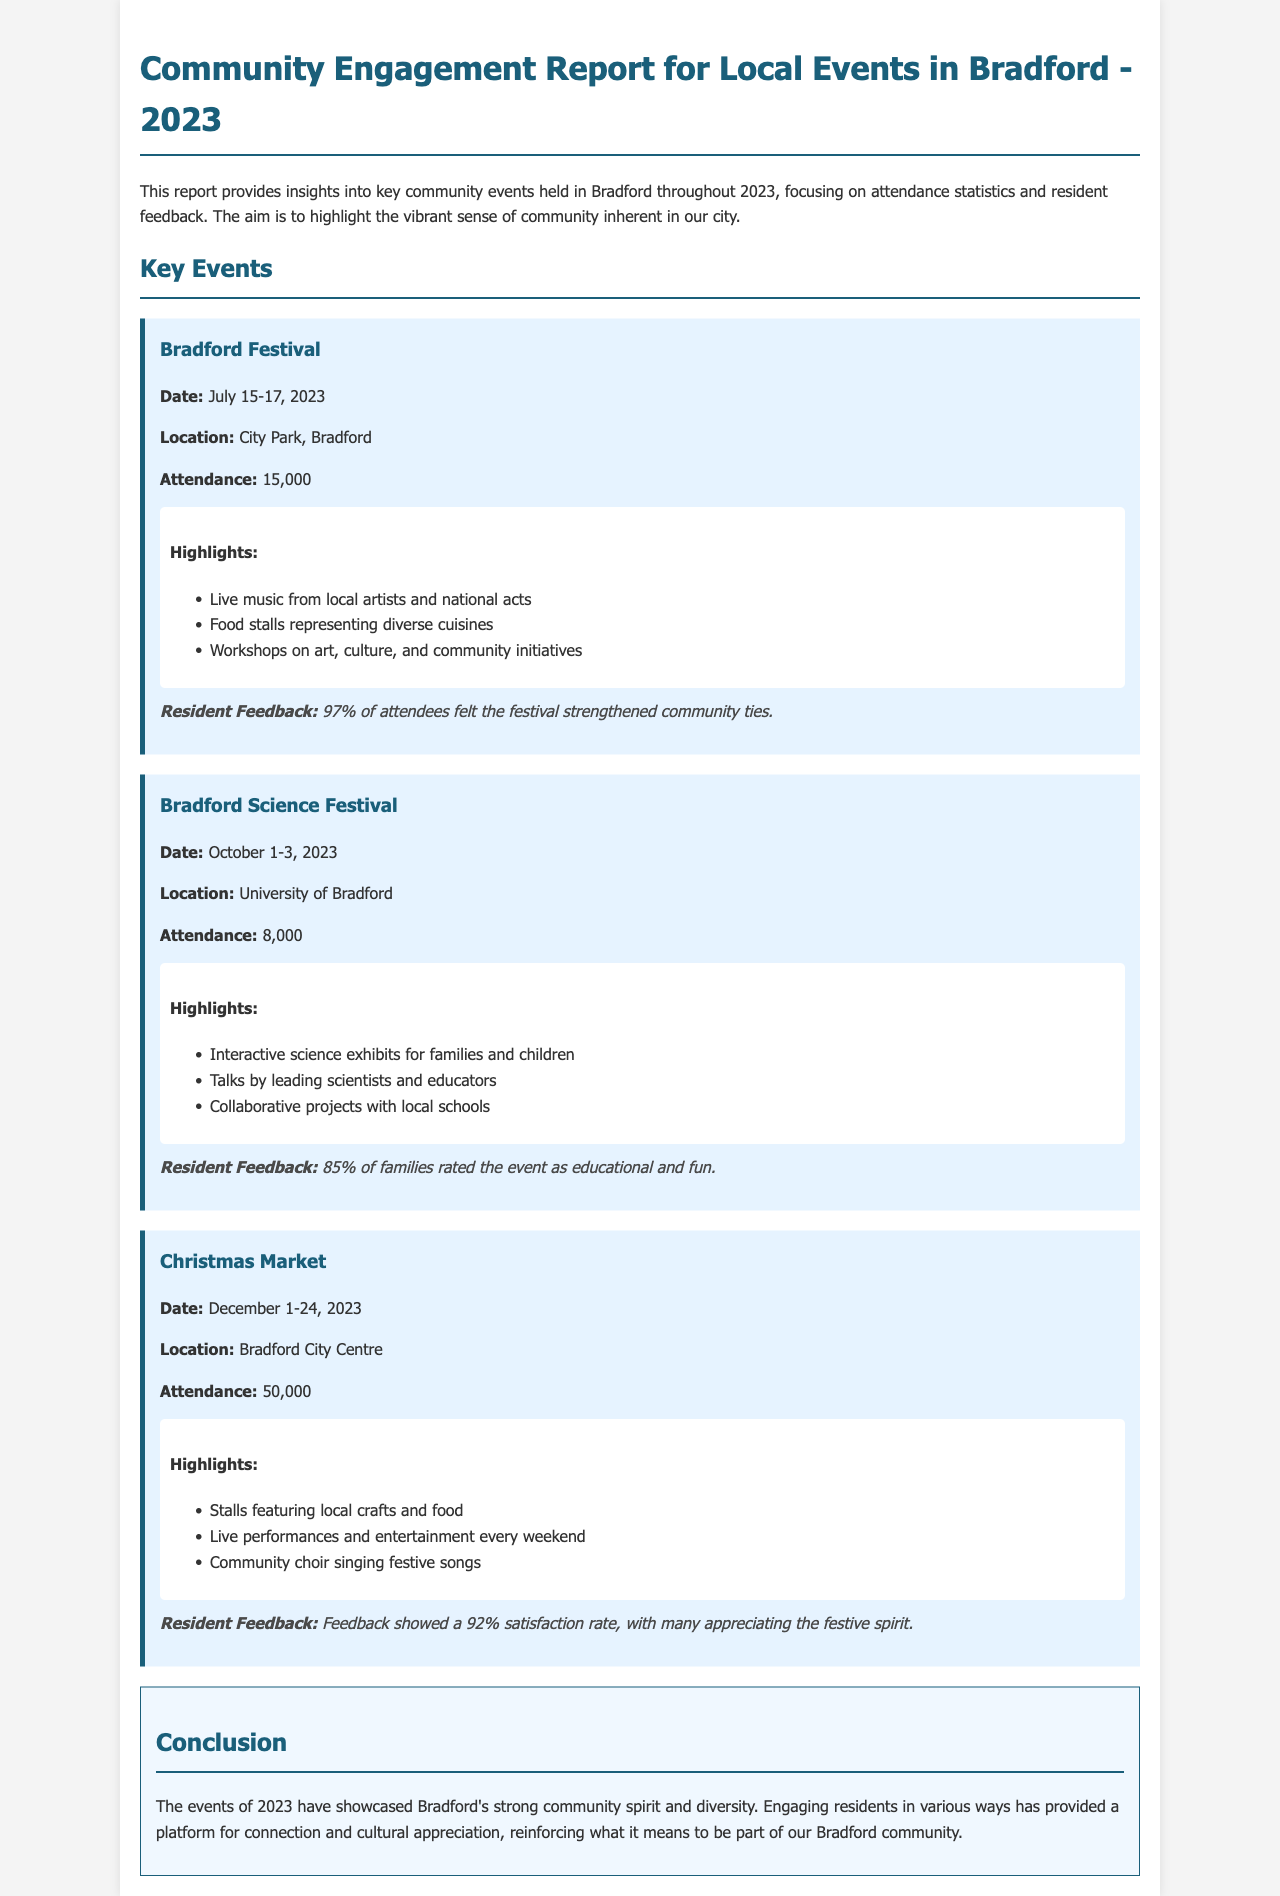What was the attendance for the Bradford Festival? The attendance for the Bradford Festival can be found in the document, which states it was 15,000.
Answer: 15,000 When did the Bradford Science Festival take place? The dates for the Bradford Science Festival are specified in the document as October 1-3, 2023.
Answer: October 1-3, 2023 What percentage of attendees felt the Bradford Festival strengthened community ties? The document provides feedback from residents, indicating that 97% felt the festival strengthened community ties.
Answer: 97% How many attendees participated in the Christmas Market? The document lists the attendance for the Christmas Market as 50,000.
Answer: 50,000 What is one highlight of the Bradford Science Festival? The highlights are outlined in the document, one being interactive science exhibits for families and children.
Answer: Interactive science exhibits What was the satisfaction rate for the Christmas Market? Resident feedback mentioned in the document indicates a 92% satisfaction rate for the Christmas Market.
Answer: 92% What type of performances were featured every weekend at the Christmas Market? The document mentions live performances as a type of entertainment featured every weekend at the Christmas Market.
Answer: Live performances What is the primary purpose of the Community Engagement Report? The report's purpose is discussed in the introduction, emphasizing insights into community events and engagement.
Answer: Insights into community events and engagement What location hosted the Bradford Festival? According to the document, the location for the Bradford Festival was City Park, Bradford.
Answer: City Park, Bradford 